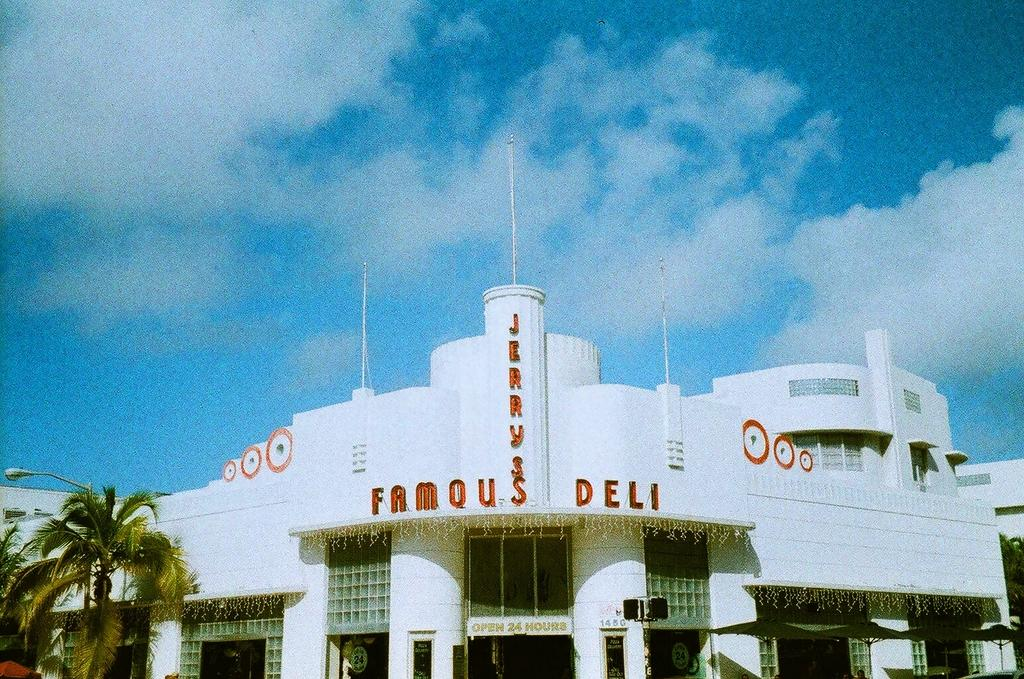<image>
Write a terse but informative summary of the picture. The sign for Jerrys Famous Deli is on a large white building. 